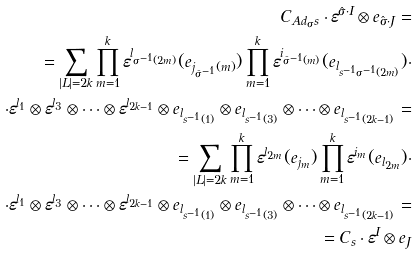Convert formula to latex. <formula><loc_0><loc_0><loc_500><loc_500>C _ { A d _ { \sigma } s } \cdot \varepsilon ^ { \hat { \sigma } \cdot I } \otimes e _ { \hat { \sigma } \cdot J } = \\ = \sum _ { | L | = 2 k } \prod _ { m = 1 } ^ { k } \varepsilon ^ { l _ { \sigma ^ { - 1 } ( 2 m ) } } ( e _ { j _ { \hat { \sigma } ^ { - 1 } } ( m ) } ) \prod _ { m = 1 } ^ { k } \varepsilon ^ { i _ { \hat { \sigma } ^ { - 1 } ( m ) } } ( e _ { l _ { s ^ { - 1 } \sigma ^ { - 1 } ( 2 m ) } } ) \cdot \\ \cdot \varepsilon ^ { l _ { 1 } } \otimes \varepsilon ^ { l _ { 3 } } \otimes \dots \otimes \varepsilon ^ { l _ { 2 k - 1 } } \otimes e _ { l _ { s ^ { - 1 } ( 1 ) } } \otimes e _ { l _ { s ^ { - 1 } ( 3 ) } } \otimes \dots \otimes e _ { l _ { s ^ { - 1 } ( 2 k - 1 ) } } = \\ = \sum _ { | L | = 2 k } \prod _ { m = 1 } ^ { k } \varepsilon ^ { l _ { 2 m } } ( e _ { j _ { m } } ) \prod _ { m = 1 } ^ { k } \varepsilon ^ { i _ { m } } ( e _ { l _ { 2 m } } ) \cdot \\ \cdot \varepsilon ^ { l _ { 1 } } \otimes \varepsilon ^ { l _ { 3 } } \otimes \dots \otimes \varepsilon ^ { l _ { 2 k - 1 } } \otimes e _ { l _ { s ^ { - 1 } ( 1 ) } } \otimes e _ { l _ { s ^ { - 1 } ( 3 ) } } \otimes \dots \otimes e _ { l _ { s ^ { - 1 } ( 2 k - 1 ) } } = \\ = C _ { s } \cdot \varepsilon ^ { I } \otimes e _ { J }</formula> 